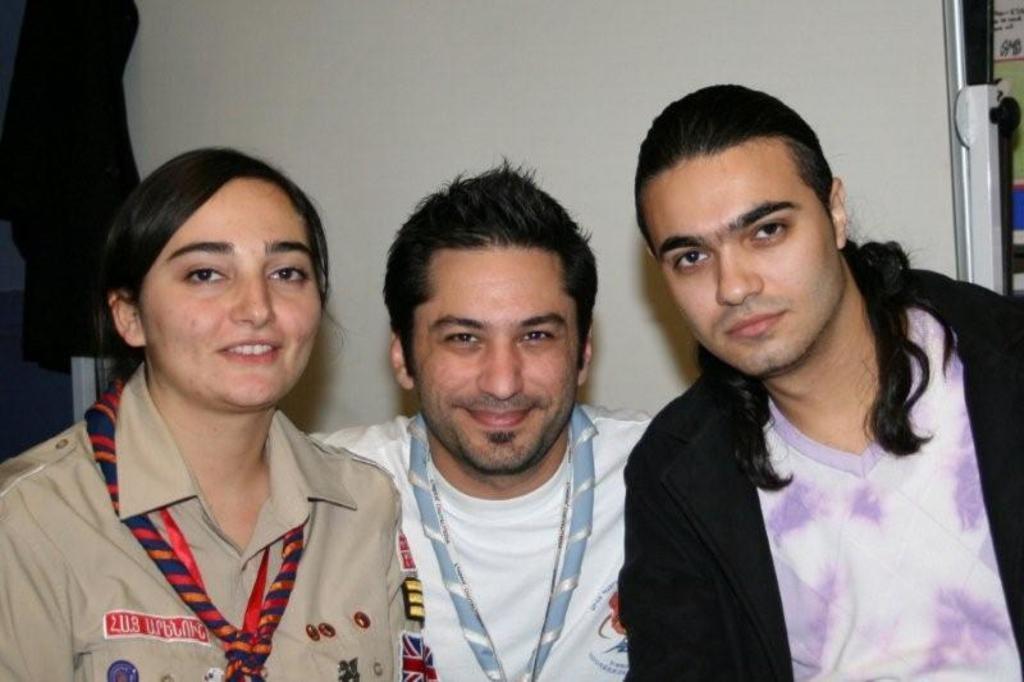Could you give a brief overview of what you see in this image? In this image we can see few people. There are few objects behind the people. 